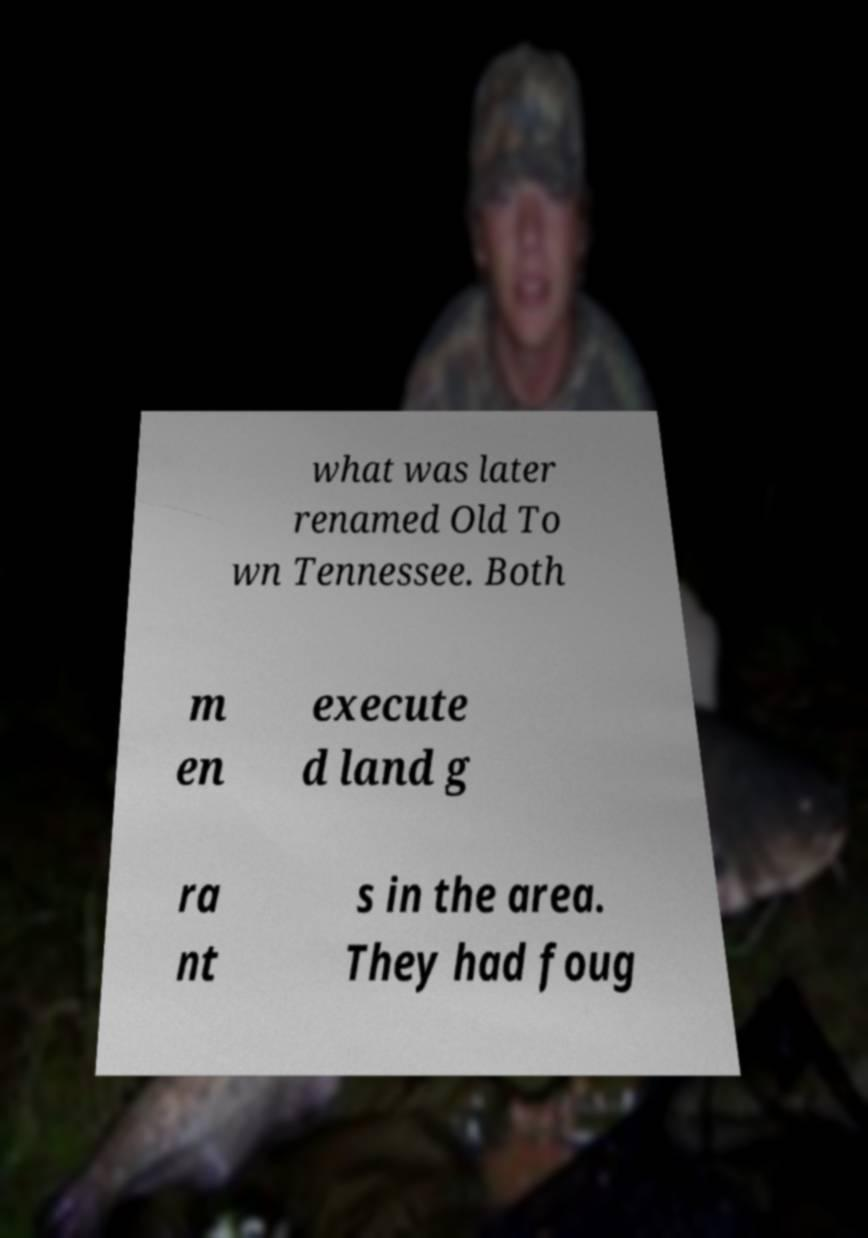Could you extract and type out the text from this image? what was later renamed Old To wn Tennessee. Both m en execute d land g ra nt s in the area. They had foug 